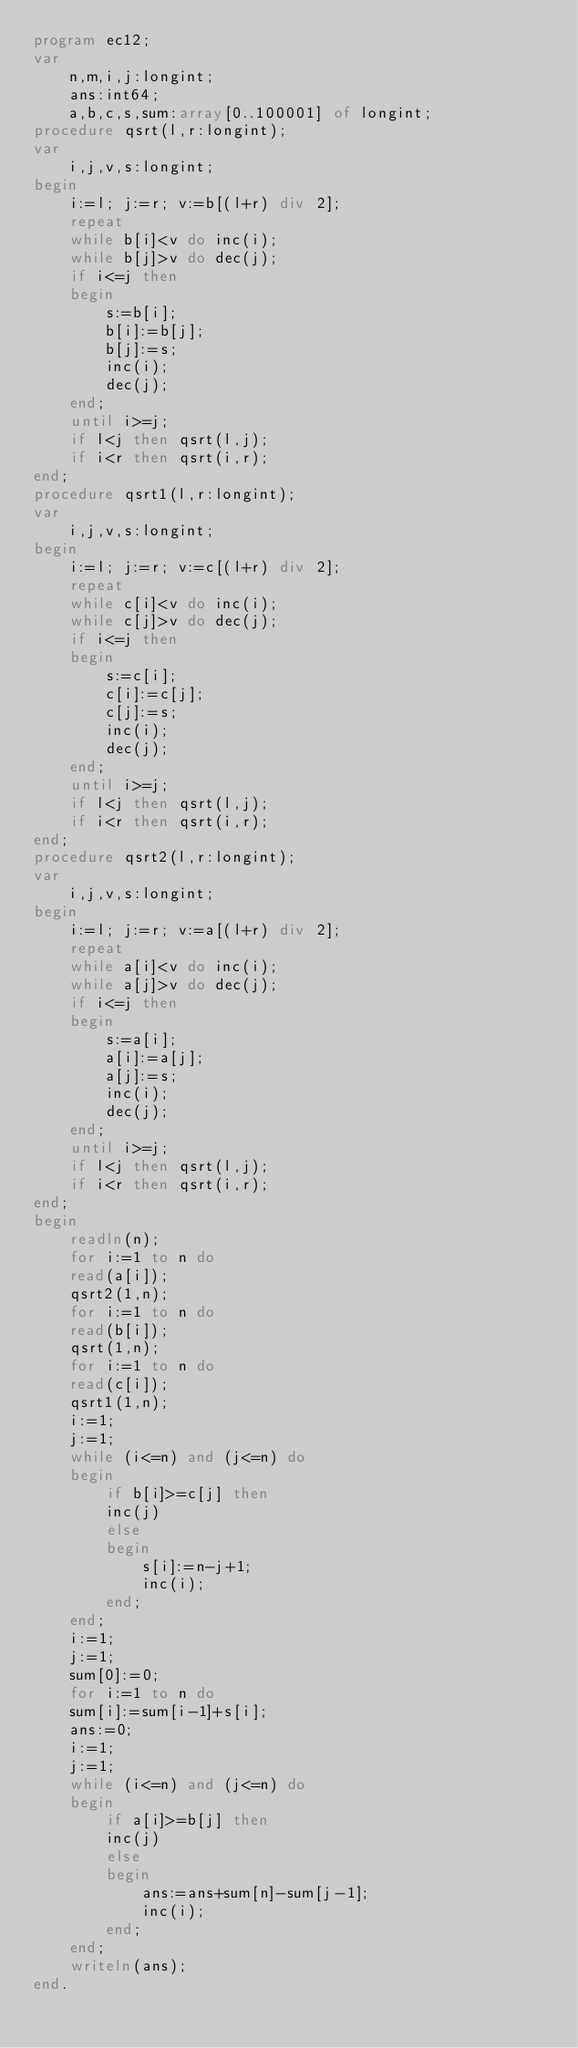Convert code to text. <code><loc_0><loc_0><loc_500><loc_500><_Pascal_>program ec12;
var 
	n,m,i,j:longint;
	ans:int64;
	a,b,c,s,sum:array[0..100001] of longint;
procedure qsrt(l,r:longint);
var 
	i,j,v,s:longint;
begin
	i:=l; j:=r; v:=b[(l+r) div 2];
	repeat
	while b[i]<v do inc(i);
	while b[j]>v do dec(j);
	if i<=j then 
	begin 
		s:=b[i];
		b[i]:=b[j];
		b[j]:=s;
		inc(i);
		dec(j);
	end;
	until i>=j;
	if l<j then qsrt(l,j);
	if i<r then qsrt(i,r);
end;
procedure qsrt1(l,r:longint);
var 
	i,j,v,s:longint;
begin
	i:=l; j:=r; v:=c[(l+r) div 2];
	repeat
	while c[i]<v do inc(i);
	while c[j]>v do dec(j);
	if i<=j then 
	begin 
		s:=c[i];
		c[i]:=c[j];
		c[j]:=s;
		inc(i);
		dec(j);
	end;
	until i>=j;
	if l<j then qsrt(l,j);
	if i<r then qsrt(i,r);
end;
procedure qsrt2(l,r:longint);
var 
	i,j,v,s:longint;
begin
	i:=l; j:=r; v:=a[(l+r) div 2];
	repeat
	while a[i]<v do inc(i);
	while a[j]>v do dec(j);
	if i<=j then 
	begin 
		s:=a[i];
		a[i]:=a[j];
		a[j]:=s;
		inc(i);
		dec(j);
	end;
	until i>=j;
	if l<j then qsrt(l,j);
	if i<r then qsrt(i,r);
end;
begin 
	readln(n);
	for i:=1 to n do
	read(a[i]);
	qsrt2(1,n);
	for i:=1 to n do
	read(b[i]);
	qsrt(1,n);
	for i:=1 to n do
	read(c[i]);
	qsrt1(1,n);
	i:=1;
	j:=1;
	while (i<=n) and (j<=n) do
	begin 
		if b[i]>=c[j] then 
		inc(j)
		else
		begin 
			s[i]:=n-j+1;
			inc(i);
		end;
	end;
	i:=1;
	j:=1;
	sum[0]:=0;
	for i:=1 to n do 
	sum[i]:=sum[i-1]+s[i];
	ans:=0;
	i:=1;
	j:=1;
	while (i<=n) and (j<=n) do 
	begin 
		if a[i]>=b[j] then 
		inc(j)
		else
		begin 
			ans:=ans+sum[n]-sum[j-1];
			inc(i);
		end;
	end;
	writeln(ans);
end. </code> 